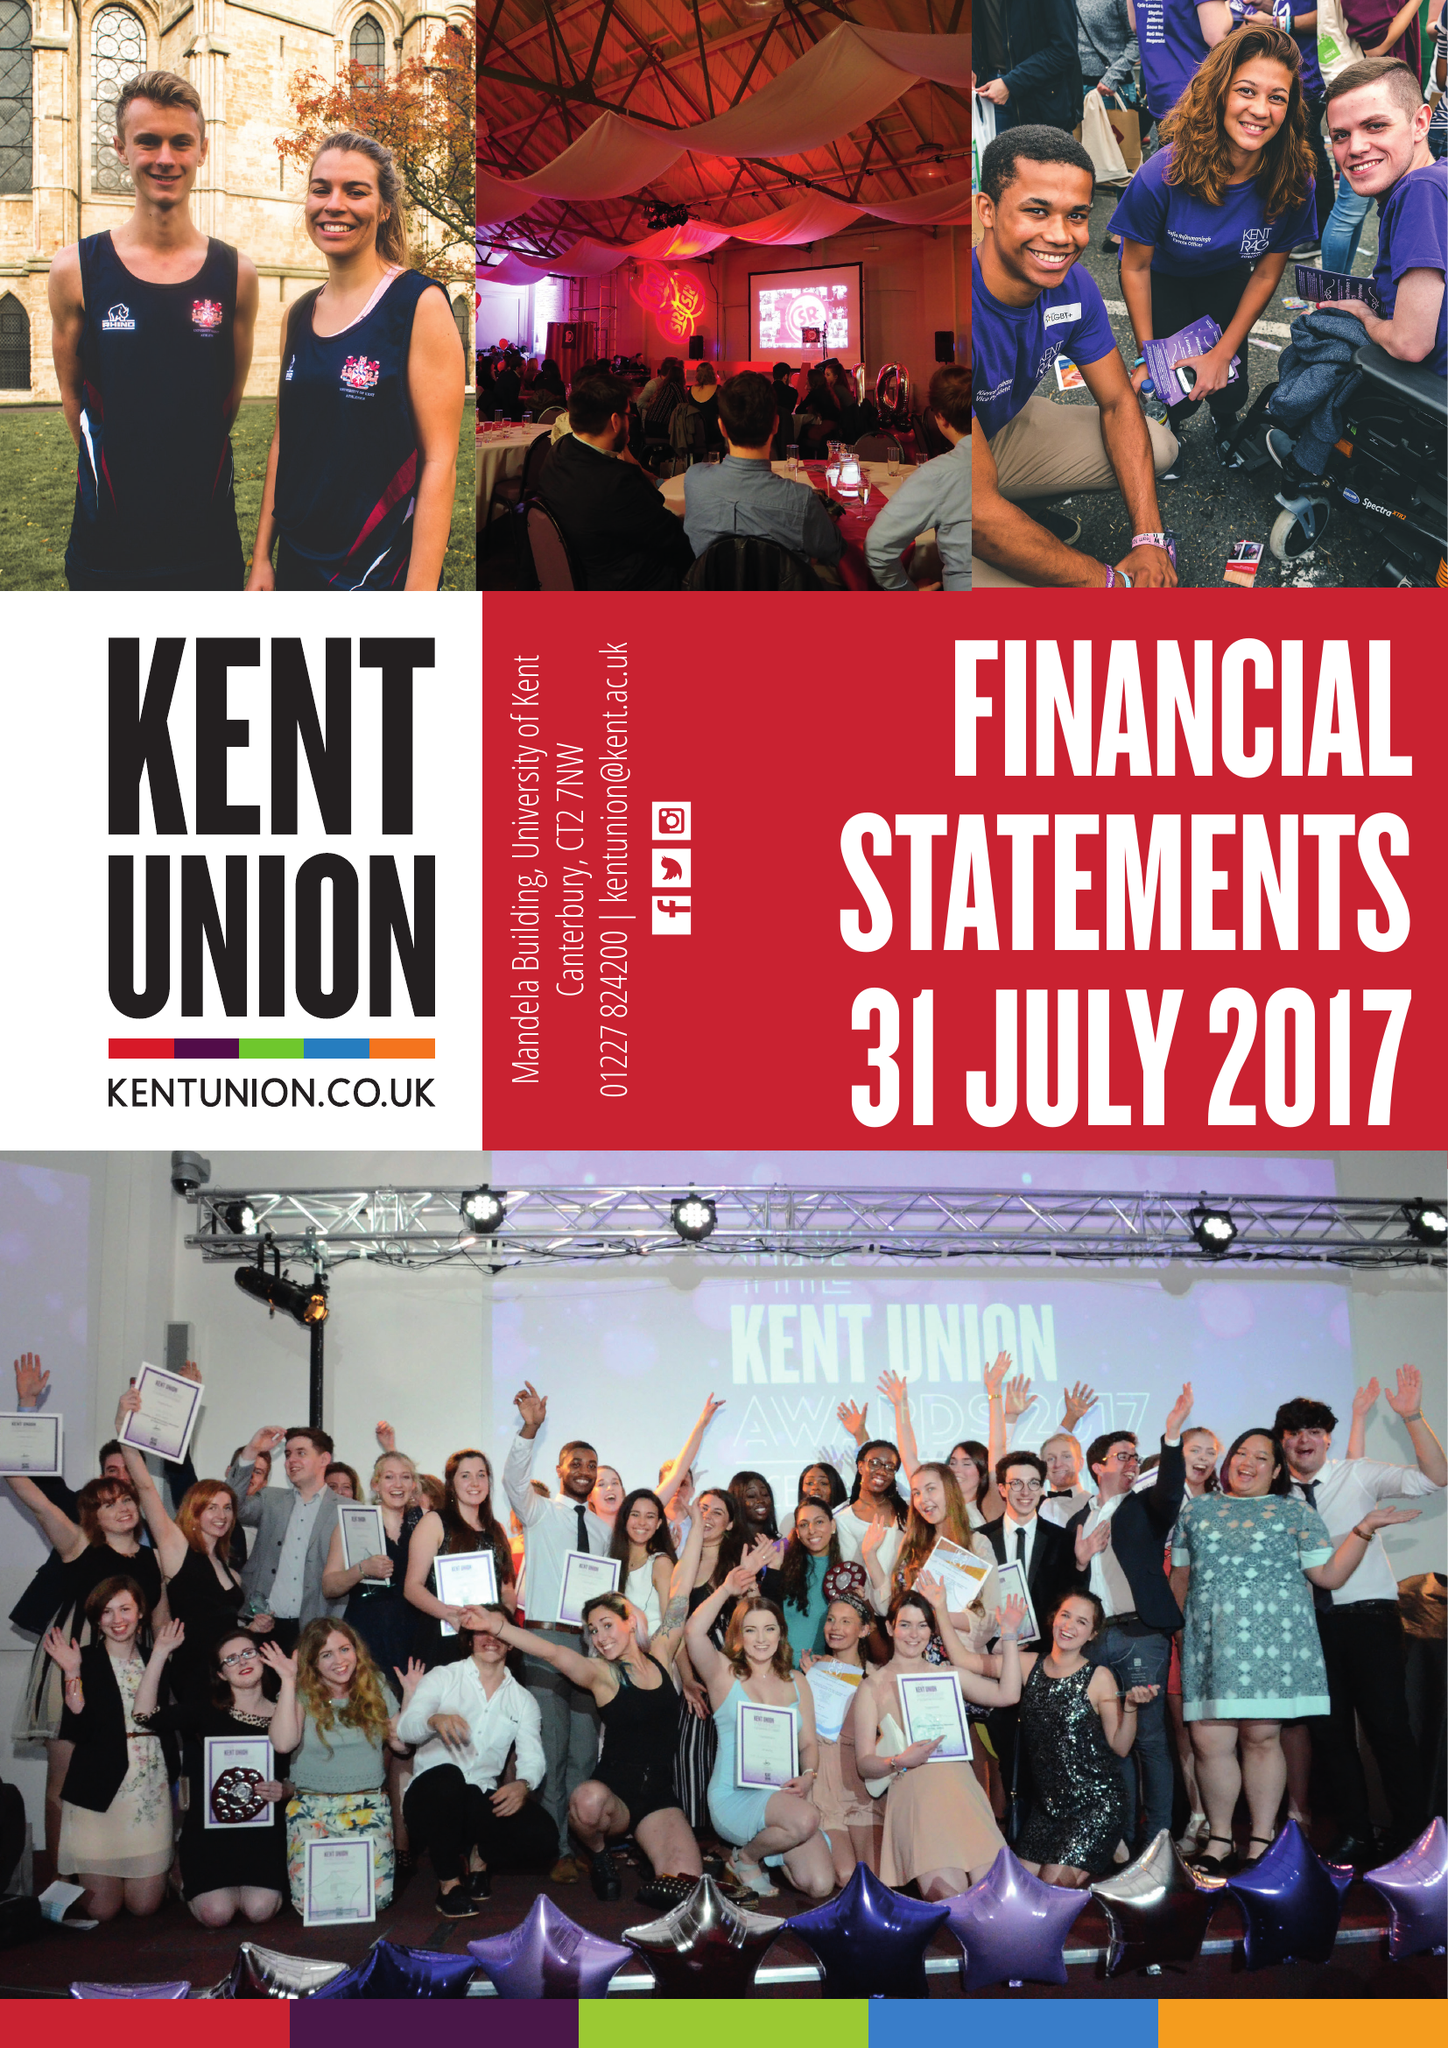What is the value for the address__postcode?
Answer the question using a single word or phrase. CT2 7NW 